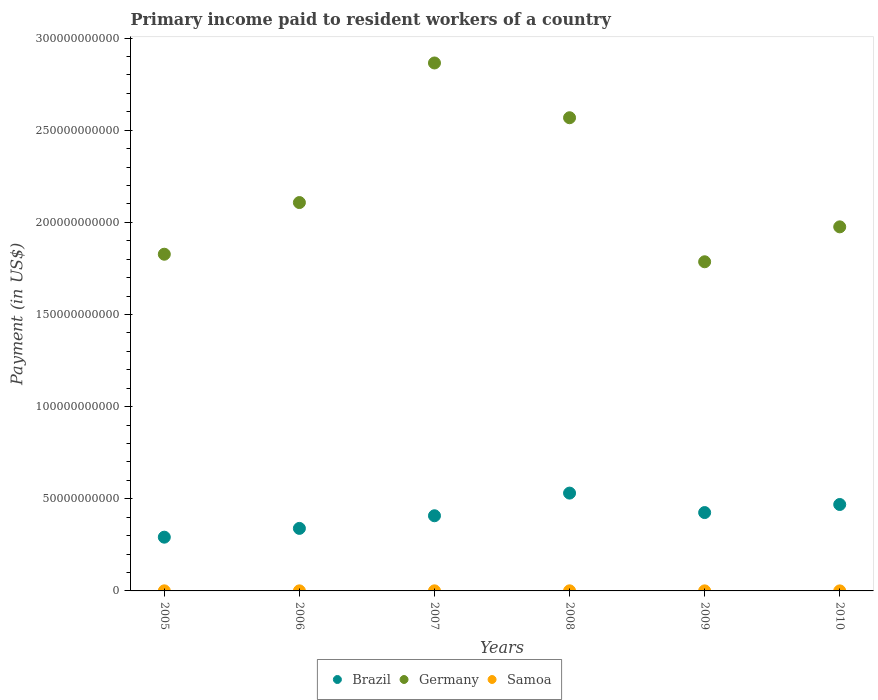How many different coloured dotlines are there?
Provide a short and direct response. 3. Is the number of dotlines equal to the number of legend labels?
Give a very brief answer. Yes. What is the amount paid to workers in Samoa in 2005?
Give a very brief answer. 4.43e+07. Across all years, what is the maximum amount paid to workers in Brazil?
Give a very brief answer. 5.31e+1. Across all years, what is the minimum amount paid to workers in Samoa?
Ensure brevity in your answer.  2.47e+07. In which year was the amount paid to workers in Samoa minimum?
Give a very brief answer. 2010. What is the total amount paid to workers in Brazil in the graph?
Provide a short and direct response. 2.46e+11. What is the difference between the amount paid to workers in Germany in 2008 and that in 2010?
Ensure brevity in your answer.  5.92e+1. What is the difference between the amount paid to workers in Brazil in 2007 and the amount paid to workers in Samoa in 2009?
Give a very brief answer. 4.08e+1. What is the average amount paid to workers in Germany per year?
Your response must be concise. 2.19e+11. In the year 2005, what is the difference between the amount paid to workers in Samoa and amount paid to workers in Germany?
Provide a short and direct response. -1.83e+11. What is the ratio of the amount paid to workers in Samoa in 2005 to that in 2009?
Give a very brief answer. 1.37. Is the amount paid to workers in Samoa in 2006 less than that in 2008?
Offer a very short reply. Yes. Is the difference between the amount paid to workers in Samoa in 2008 and 2009 greater than the difference between the amount paid to workers in Germany in 2008 and 2009?
Offer a terse response. No. What is the difference between the highest and the second highest amount paid to workers in Germany?
Offer a terse response. 2.97e+1. What is the difference between the highest and the lowest amount paid to workers in Brazil?
Give a very brief answer. 2.39e+1. In how many years, is the amount paid to workers in Germany greater than the average amount paid to workers in Germany taken over all years?
Give a very brief answer. 2. Is the sum of the amount paid to workers in Germany in 2008 and 2009 greater than the maximum amount paid to workers in Samoa across all years?
Offer a very short reply. Yes. Does the amount paid to workers in Samoa monotonically increase over the years?
Offer a terse response. No. Does the graph contain any zero values?
Keep it short and to the point. No. Does the graph contain grids?
Provide a short and direct response. No. Where does the legend appear in the graph?
Offer a very short reply. Bottom center. How many legend labels are there?
Offer a terse response. 3. How are the legend labels stacked?
Provide a succinct answer. Horizontal. What is the title of the graph?
Offer a very short reply. Primary income paid to resident workers of a country. What is the label or title of the Y-axis?
Offer a terse response. Payment (in US$). What is the Payment (in US$) in Brazil in 2005?
Make the answer very short. 2.92e+1. What is the Payment (in US$) of Germany in 2005?
Your response must be concise. 1.83e+11. What is the Payment (in US$) of Samoa in 2005?
Ensure brevity in your answer.  4.43e+07. What is the Payment (in US$) in Brazil in 2006?
Provide a short and direct response. 3.39e+1. What is the Payment (in US$) in Germany in 2006?
Provide a short and direct response. 2.11e+11. What is the Payment (in US$) in Samoa in 2006?
Offer a very short reply. 3.93e+07. What is the Payment (in US$) in Brazil in 2007?
Provide a short and direct response. 4.08e+1. What is the Payment (in US$) in Germany in 2007?
Offer a very short reply. 2.86e+11. What is the Payment (in US$) of Samoa in 2007?
Ensure brevity in your answer.  4.62e+07. What is the Payment (in US$) of Brazil in 2008?
Make the answer very short. 5.31e+1. What is the Payment (in US$) of Germany in 2008?
Ensure brevity in your answer.  2.57e+11. What is the Payment (in US$) in Samoa in 2008?
Your answer should be very brief. 5.44e+07. What is the Payment (in US$) in Brazil in 2009?
Keep it short and to the point. 4.25e+1. What is the Payment (in US$) in Germany in 2009?
Offer a very short reply. 1.79e+11. What is the Payment (in US$) of Samoa in 2009?
Ensure brevity in your answer.  3.24e+07. What is the Payment (in US$) of Brazil in 2010?
Make the answer very short. 4.69e+1. What is the Payment (in US$) of Germany in 2010?
Provide a succinct answer. 1.98e+11. What is the Payment (in US$) in Samoa in 2010?
Make the answer very short. 2.47e+07. Across all years, what is the maximum Payment (in US$) of Brazil?
Your response must be concise. 5.31e+1. Across all years, what is the maximum Payment (in US$) of Germany?
Offer a terse response. 2.86e+11. Across all years, what is the maximum Payment (in US$) of Samoa?
Provide a short and direct response. 5.44e+07. Across all years, what is the minimum Payment (in US$) in Brazil?
Keep it short and to the point. 2.92e+1. Across all years, what is the minimum Payment (in US$) of Germany?
Your answer should be compact. 1.79e+11. Across all years, what is the minimum Payment (in US$) in Samoa?
Offer a very short reply. 2.47e+07. What is the total Payment (in US$) in Brazil in the graph?
Your response must be concise. 2.46e+11. What is the total Payment (in US$) in Germany in the graph?
Provide a short and direct response. 1.31e+12. What is the total Payment (in US$) in Samoa in the graph?
Make the answer very short. 2.41e+08. What is the difference between the Payment (in US$) of Brazil in 2005 and that in 2006?
Offer a very short reply. -4.77e+09. What is the difference between the Payment (in US$) of Germany in 2005 and that in 2006?
Provide a succinct answer. -2.80e+1. What is the difference between the Payment (in US$) of Samoa in 2005 and that in 2006?
Ensure brevity in your answer.  5.01e+06. What is the difference between the Payment (in US$) in Brazil in 2005 and that in 2007?
Give a very brief answer. -1.16e+1. What is the difference between the Payment (in US$) in Germany in 2005 and that in 2007?
Keep it short and to the point. -1.04e+11. What is the difference between the Payment (in US$) in Samoa in 2005 and that in 2007?
Ensure brevity in your answer.  -1.87e+06. What is the difference between the Payment (in US$) in Brazil in 2005 and that in 2008?
Your answer should be very brief. -2.39e+1. What is the difference between the Payment (in US$) in Germany in 2005 and that in 2008?
Offer a terse response. -7.41e+1. What is the difference between the Payment (in US$) of Samoa in 2005 and that in 2008?
Give a very brief answer. -1.00e+07. What is the difference between the Payment (in US$) of Brazil in 2005 and that in 2009?
Ensure brevity in your answer.  -1.33e+1. What is the difference between the Payment (in US$) of Germany in 2005 and that in 2009?
Your answer should be compact. 4.10e+09. What is the difference between the Payment (in US$) in Samoa in 2005 and that in 2009?
Offer a terse response. 1.20e+07. What is the difference between the Payment (in US$) of Brazil in 2005 and that in 2010?
Offer a very short reply. -1.77e+1. What is the difference between the Payment (in US$) in Germany in 2005 and that in 2010?
Your answer should be very brief. -1.49e+1. What is the difference between the Payment (in US$) in Samoa in 2005 and that in 2010?
Your answer should be very brief. 1.97e+07. What is the difference between the Payment (in US$) of Brazil in 2006 and that in 2007?
Your answer should be compact. -6.86e+09. What is the difference between the Payment (in US$) of Germany in 2006 and that in 2007?
Offer a terse response. -7.57e+1. What is the difference between the Payment (in US$) in Samoa in 2006 and that in 2007?
Your response must be concise. -6.88e+06. What is the difference between the Payment (in US$) of Brazil in 2006 and that in 2008?
Your answer should be compact. -1.91e+1. What is the difference between the Payment (in US$) of Germany in 2006 and that in 2008?
Provide a short and direct response. -4.60e+1. What is the difference between the Payment (in US$) of Samoa in 2006 and that in 2008?
Your answer should be very brief. -1.50e+07. What is the difference between the Payment (in US$) in Brazil in 2006 and that in 2009?
Keep it short and to the point. -8.58e+09. What is the difference between the Payment (in US$) of Germany in 2006 and that in 2009?
Provide a short and direct response. 3.21e+1. What is the difference between the Payment (in US$) in Samoa in 2006 and that in 2009?
Your answer should be very brief. 6.98e+06. What is the difference between the Payment (in US$) of Brazil in 2006 and that in 2010?
Keep it short and to the point. -1.30e+1. What is the difference between the Payment (in US$) in Germany in 2006 and that in 2010?
Make the answer very short. 1.32e+1. What is the difference between the Payment (in US$) in Samoa in 2006 and that in 2010?
Offer a very short reply. 1.47e+07. What is the difference between the Payment (in US$) in Brazil in 2007 and that in 2008?
Ensure brevity in your answer.  -1.23e+1. What is the difference between the Payment (in US$) in Germany in 2007 and that in 2008?
Make the answer very short. 2.97e+1. What is the difference between the Payment (in US$) of Samoa in 2007 and that in 2008?
Provide a succinct answer. -8.16e+06. What is the difference between the Payment (in US$) of Brazil in 2007 and that in 2009?
Give a very brief answer. -1.73e+09. What is the difference between the Payment (in US$) in Germany in 2007 and that in 2009?
Make the answer very short. 1.08e+11. What is the difference between the Payment (in US$) in Samoa in 2007 and that in 2009?
Provide a succinct answer. 1.39e+07. What is the difference between the Payment (in US$) in Brazil in 2007 and that in 2010?
Keep it short and to the point. -6.11e+09. What is the difference between the Payment (in US$) of Germany in 2007 and that in 2010?
Your answer should be very brief. 8.89e+1. What is the difference between the Payment (in US$) of Samoa in 2007 and that in 2010?
Give a very brief answer. 2.15e+07. What is the difference between the Payment (in US$) in Brazil in 2008 and that in 2009?
Ensure brevity in your answer.  1.06e+1. What is the difference between the Payment (in US$) of Germany in 2008 and that in 2009?
Make the answer very short. 7.82e+1. What is the difference between the Payment (in US$) in Samoa in 2008 and that in 2009?
Offer a terse response. 2.20e+07. What is the difference between the Payment (in US$) of Brazil in 2008 and that in 2010?
Offer a very short reply. 6.18e+09. What is the difference between the Payment (in US$) of Germany in 2008 and that in 2010?
Your response must be concise. 5.92e+1. What is the difference between the Payment (in US$) in Samoa in 2008 and that in 2010?
Make the answer very short. 2.97e+07. What is the difference between the Payment (in US$) of Brazil in 2009 and that in 2010?
Keep it short and to the point. -4.38e+09. What is the difference between the Payment (in US$) in Germany in 2009 and that in 2010?
Ensure brevity in your answer.  -1.90e+1. What is the difference between the Payment (in US$) of Samoa in 2009 and that in 2010?
Offer a very short reply. 7.68e+06. What is the difference between the Payment (in US$) of Brazil in 2005 and the Payment (in US$) of Germany in 2006?
Your response must be concise. -1.82e+11. What is the difference between the Payment (in US$) in Brazil in 2005 and the Payment (in US$) in Samoa in 2006?
Your answer should be very brief. 2.91e+1. What is the difference between the Payment (in US$) in Germany in 2005 and the Payment (in US$) in Samoa in 2006?
Keep it short and to the point. 1.83e+11. What is the difference between the Payment (in US$) of Brazil in 2005 and the Payment (in US$) of Germany in 2007?
Offer a very short reply. -2.57e+11. What is the difference between the Payment (in US$) in Brazil in 2005 and the Payment (in US$) in Samoa in 2007?
Make the answer very short. 2.91e+1. What is the difference between the Payment (in US$) of Germany in 2005 and the Payment (in US$) of Samoa in 2007?
Keep it short and to the point. 1.83e+11. What is the difference between the Payment (in US$) in Brazil in 2005 and the Payment (in US$) in Germany in 2008?
Keep it short and to the point. -2.28e+11. What is the difference between the Payment (in US$) in Brazil in 2005 and the Payment (in US$) in Samoa in 2008?
Your response must be concise. 2.91e+1. What is the difference between the Payment (in US$) in Germany in 2005 and the Payment (in US$) in Samoa in 2008?
Keep it short and to the point. 1.83e+11. What is the difference between the Payment (in US$) in Brazil in 2005 and the Payment (in US$) in Germany in 2009?
Your response must be concise. -1.49e+11. What is the difference between the Payment (in US$) in Brazil in 2005 and the Payment (in US$) in Samoa in 2009?
Your answer should be very brief. 2.91e+1. What is the difference between the Payment (in US$) in Germany in 2005 and the Payment (in US$) in Samoa in 2009?
Your answer should be compact. 1.83e+11. What is the difference between the Payment (in US$) of Brazil in 2005 and the Payment (in US$) of Germany in 2010?
Provide a succinct answer. -1.68e+11. What is the difference between the Payment (in US$) in Brazil in 2005 and the Payment (in US$) in Samoa in 2010?
Provide a succinct answer. 2.91e+1. What is the difference between the Payment (in US$) of Germany in 2005 and the Payment (in US$) of Samoa in 2010?
Your answer should be compact. 1.83e+11. What is the difference between the Payment (in US$) of Brazil in 2006 and the Payment (in US$) of Germany in 2007?
Your answer should be compact. -2.53e+11. What is the difference between the Payment (in US$) in Brazil in 2006 and the Payment (in US$) in Samoa in 2007?
Provide a succinct answer. 3.39e+1. What is the difference between the Payment (in US$) in Germany in 2006 and the Payment (in US$) in Samoa in 2007?
Provide a succinct answer. 2.11e+11. What is the difference between the Payment (in US$) of Brazil in 2006 and the Payment (in US$) of Germany in 2008?
Ensure brevity in your answer.  -2.23e+11. What is the difference between the Payment (in US$) in Brazil in 2006 and the Payment (in US$) in Samoa in 2008?
Ensure brevity in your answer.  3.39e+1. What is the difference between the Payment (in US$) of Germany in 2006 and the Payment (in US$) of Samoa in 2008?
Offer a terse response. 2.11e+11. What is the difference between the Payment (in US$) in Brazil in 2006 and the Payment (in US$) in Germany in 2009?
Your response must be concise. -1.45e+11. What is the difference between the Payment (in US$) in Brazil in 2006 and the Payment (in US$) in Samoa in 2009?
Offer a terse response. 3.39e+1. What is the difference between the Payment (in US$) in Germany in 2006 and the Payment (in US$) in Samoa in 2009?
Keep it short and to the point. 2.11e+11. What is the difference between the Payment (in US$) of Brazil in 2006 and the Payment (in US$) of Germany in 2010?
Offer a terse response. -1.64e+11. What is the difference between the Payment (in US$) in Brazil in 2006 and the Payment (in US$) in Samoa in 2010?
Your answer should be very brief. 3.39e+1. What is the difference between the Payment (in US$) of Germany in 2006 and the Payment (in US$) of Samoa in 2010?
Give a very brief answer. 2.11e+11. What is the difference between the Payment (in US$) of Brazil in 2007 and the Payment (in US$) of Germany in 2008?
Give a very brief answer. -2.16e+11. What is the difference between the Payment (in US$) of Brazil in 2007 and the Payment (in US$) of Samoa in 2008?
Provide a short and direct response. 4.07e+1. What is the difference between the Payment (in US$) of Germany in 2007 and the Payment (in US$) of Samoa in 2008?
Make the answer very short. 2.86e+11. What is the difference between the Payment (in US$) in Brazil in 2007 and the Payment (in US$) in Germany in 2009?
Keep it short and to the point. -1.38e+11. What is the difference between the Payment (in US$) of Brazil in 2007 and the Payment (in US$) of Samoa in 2009?
Provide a short and direct response. 4.08e+1. What is the difference between the Payment (in US$) in Germany in 2007 and the Payment (in US$) in Samoa in 2009?
Provide a succinct answer. 2.86e+11. What is the difference between the Payment (in US$) in Brazil in 2007 and the Payment (in US$) in Germany in 2010?
Keep it short and to the point. -1.57e+11. What is the difference between the Payment (in US$) in Brazil in 2007 and the Payment (in US$) in Samoa in 2010?
Provide a succinct answer. 4.08e+1. What is the difference between the Payment (in US$) in Germany in 2007 and the Payment (in US$) in Samoa in 2010?
Ensure brevity in your answer.  2.86e+11. What is the difference between the Payment (in US$) of Brazil in 2008 and the Payment (in US$) of Germany in 2009?
Provide a succinct answer. -1.26e+11. What is the difference between the Payment (in US$) in Brazil in 2008 and the Payment (in US$) in Samoa in 2009?
Your answer should be compact. 5.30e+1. What is the difference between the Payment (in US$) of Germany in 2008 and the Payment (in US$) of Samoa in 2009?
Provide a succinct answer. 2.57e+11. What is the difference between the Payment (in US$) in Brazil in 2008 and the Payment (in US$) in Germany in 2010?
Your response must be concise. -1.44e+11. What is the difference between the Payment (in US$) of Brazil in 2008 and the Payment (in US$) of Samoa in 2010?
Ensure brevity in your answer.  5.30e+1. What is the difference between the Payment (in US$) of Germany in 2008 and the Payment (in US$) of Samoa in 2010?
Make the answer very short. 2.57e+11. What is the difference between the Payment (in US$) in Brazil in 2009 and the Payment (in US$) in Germany in 2010?
Your answer should be compact. -1.55e+11. What is the difference between the Payment (in US$) in Brazil in 2009 and the Payment (in US$) in Samoa in 2010?
Make the answer very short. 4.25e+1. What is the difference between the Payment (in US$) in Germany in 2009 and the Payment (in US$) in Samoa in 2010?
Keep it short and to the point. 1.79e+11. What is the average Payment (in US$) of Brazil per year?
Make the answer very short. 4.11e+1. What is the average Payment (in US$) in Germany per year?
Provide a short and direct response. 2.19e+11. What is the average Payment (in US$) in Samoa per year?
Keep it short and to the point. 4.02e+07. In the year 2005, what is the difference between the Payment (in US$) of Brazil and Payment (in US$) of Germany?
Ensure brevity in your answer.  -1.54e+11. In the year 2005, what is the difference between the Payment (in US$) of Brazil and Payment (in US$) of Samoa?
Make the answer very short. 2.91e+1. In the year 2005, what is the difference between the Payment (in US$) of Germany and Payment (in US$) of Samoa?
Offer a very short reply. 1.83e+11. In the year 2006, what is the difference between the Payment (in US$) of Brazil and Payment (in US$) of Germany?
Provide a succinct answer. -1.77e+11. In the year 2006, what is the difference between the Payment (in US$) of Brazil and Payment (in US$) of Samoa?
Your answer should be very brief. 3.39e+1. In the year 2006, what is the difference between the Payment (in US$) in Germany and Payment (in US$) in Samoa?
Provide a succinct answer. 2.11e+11. In the year 2007, what is the difference between the Payment (in US$) of Brazil and Payment (in US$) of Germany?
Provide a short and direct response. -2.46e+11. In the year 2007, what is the difference between the Payment (in US$) in Brazil and Payment (in US$) in Samoa?
Offer a very short reply. 4.07e+1. In the year 2007, what is the difference between the Payment (in US$) in Germany and Payment (in US$) in Samoa?
Keep it short and to the point. 2.86e+11. In the year 2008, what is the difference between the Payment (in US$) of Brazil and Payment (in US$) of Germany?
Give a very brief answer. -2.04e+11. In the year 2008, what is the difference between the Payment (in US$) in Brazil and Payment (in US$) in Samoa?
Give a very brief answer. 5.30e+1. In the year 2008, what is the difference between the Payment (in US$) in Germany and Payment (in US$) in Samoa?
Offer a very short reply. 2.57e+11. In the year 2009, what is the difference between the Payment (in US$) in Brazil and Payment (in US$) in Germany?
Keep it short and to the point. -1.36e+11. In the year 2009, what is the difference between the Payment (in US$) of Brazil and Payment (in US$) of Samoa?
Offer a very short reply. 4.25e+1. In the year 2009, what is the difference between the Payment (in US$) in Germany and Payment (in US$) in Samoa?
Make the answer very short. 1.79e+11. In the year 2010, what is the difference between the Payment (in US$) in Brazil and Payment (in US$) in Germany?
Ensure brevity in your answer.  -1.51e+11. In the year 2010, what is the difference between the Payment (in US$) of Brazil and Payment (in US$) of Samoa?
Make the answer very short. 4.69e+1. In the year 2010, what is the difference between the Payment (in US$) of Germany and Payment (in US$) of Samoa?
Ensure brevity in your answer.  1.98e+11. What is the ratio of the Payment (in US$) in Brazil in 2005 to that in 2006?
Provide a short and direct response. 0.86. What is the ratio of the Payment (in US$) of Germany in 2005 to that in 2006?
Offer a terse response. 0.87. What is the ratio of the Payment (in US$) of Samoa in 2005 to that in 2006?
Your answer should be very brief. 1.13. What is the ratio of the Payment (in US$) in Brazil in 2005 to that in 2007?
Your answer should be very brief. 0.71. What is the ratio of the Payment (in US$) of Germany in 2005 to that in 2007?
Offer a very short reply. 0.64. What is the ratio of the Payment (in US$) of Samoa in 2005 to that in 2007?
Make the answer very short. 0.96. What is the ratio of the Payment (in US$) of Brazil in 2005 to that in 2008?
Offer a terse response. 0.55. What is the ratio of the Payment (in US$) of Germany in 2005 to that in 2008?
Offer a very short reply. 0.71. What is the ratio of the Payment (in US$) of Samoa in 2005 to that in 2008?
Keep it short and to the point. 0.82. What is the ratio of the Payment (in US$) of Brazil in 2005 to that in 2009?
Keep it short and to the point. 0.69. What is the ratio of the Payment (in US$) in Germany in 2005 to that in 2009?
Make the answer very short. 1.02. What is the ratio of the Payment (in US$) of Samoa in 2005 to that in 2009?
Your answer should be very brief. 1.37. What is the ratio of the Payment (in US$) in Brazil in 2005 to that in 2010?
Provide a succinct answer. 0.62. What is the ratio of the Payment (in US$) in Germany in 2005 to that in 2010?
Give a very brief answer. 0.92. What is the ratio of the Payment (in US$) of Samoa in 2005 to that in 2010?
Your answer should be very brief. 1.8. What is the ratio of the Payment (in US$) of Brazil in 2006 to that in 2007?
Provide a short and direct response. 0.83. What is the ratio of the Payment (in US$) of Germany in 2006 to that in 2007?
Give a very brief answer. 0.74. What is the ratio of the Payment (in US$) in Samoa in 2006 to that in 2007?
Keep it short and to the point. 0.85. What is the ratio of the Payment (in US$) in Brazil in 2006 to that in 2008?
Your answer should be compact. 0.64. What is the ratio of the Payment (in US$) in Germany in 2006 to that in 2008?
Keep it short and to the point. 0.82. What is the ratio of the Payment (in US$) of Samoa in 2006 to that in 2008?
Offer a terse response. 0.72. What is the ratio of the Payment (in US$) in Brazil in 2006 to that in 2009?
Make the answer very short. 0.8. What is the ratio of the Payment (in US$) of Germany in 2006 to that in 2009?
Your response must be concise. 1.18. What is the ratio of the Payment (in US$) of Samoa in 2006 to that in 2009?
Provide a short and direct response. 1.22. What is the ratio of the Payment (in US$) in Brazil in 2006 to that in 2010?
Give a very brief answer. 0.72. What is the ratio of the Payment (in US$) in Germany in 2006 to that in 2010?
Provide a short and direct response. 1.07. What is the ratio of the Payment (in US$) in Samoa in 2006 to that in 2010?
Offer a terse response. 1.59. What is the ratio of the Payment (in US$) of Brazil in 2007 to that in 2008?
Provide a short and direct response. 0.77. What is the ratio of the Payment (in US$) of Germany in 2007 to that in 2008?
Offer a very short reply. 1.12. What is the ratio of the Payment (in US$) of Samoa in 2007 to that in 2008?
Make the answer very short. 0.85. What is the ratio of the Payment (in US$) of Brazil in 2007 to that in 2009?
Make the answer very short. 0.96. What is the ratio of the Payment (in US$) of Germany in 2007 to that in 2009?
Offer a terse response. 1.6. What is the ratio of the Payment (in US$) of Samoa in 2007 to that in 2009?
Keep it short and to the point. 1.43. What is the ratio of the Payment (in US$) of Brazil in 2007 to that in 2010?
Make the answer very short. 0.87. What is the ratio of the Payment (in US$) of Germany in 2007 to that in 2010?
Your response must be concise. 1.45. What is the ratio of the Payment (in US$) in Samoa in 2007 to that in 2010?
Your answer should be very brief. 1.87. What is the ratio of the Payment (in US$) of Brazil in 2008 to that in 2009?
Offer a very short reply. 1.25. What is the ratio of the Payment (in US$) of Germany in 2008 to that in 2009?
Offer a terse response. 1.44. What is the ratio of the Payment (in US$) of Samoa in 2008 to that in 2009?
Provide a short and direct response. 1.68. What is the ratio of the Payment (in US$) of Brazil in 2008 to that in 2010?
Ensure brevity in your answer.  1.13. What is the ratio of the Payment (in US$) of Germany in 2008 to that in 2010?
Provide a short and direct response. 1.3. What is the ratio of the Payment (in US$) in Samoa in 2008 to that in 2010?
Your answer should be very brief. 2.2. What is the ratio of the Payment (in US$) in Brazil in 2009 to that in 2010?
Offer a very short reply. 0.91. What is the ratio of the Payment (in US$) in Germany in 2009 to that in 2010?
Provide a short and direct response. 0.9. What is the ratio of the Payment (in US$) of Samoa in 2009 to that in 2010?
Your answer should be compact. 1.31. What is the difference between the highest and the second highest Payment (in US$) of Brazil?
Make the answer very short. 6.18e+09. What is the difference between the highest and the second highest Payment (in US$) of Germany?
Your response must be concise. 2.97e+1. What is the difference between the highest and the second highest Payment (in US$) of Samoa?
Keep it short and to the point. 8.16e+06. What is the difference between the highest and the lowest Payment (in US$) in Brazil?
Ensure brevity in your answer.  2.39e+1. What is the difference between the highest and the lowest Payment (in US$) in Germany?
Give a very brief answer. 1.08e+11. What is the difference between the highest and the lowest Payment (in US$) in Samoa?
Your answer should be compact. 2.97e+07. 